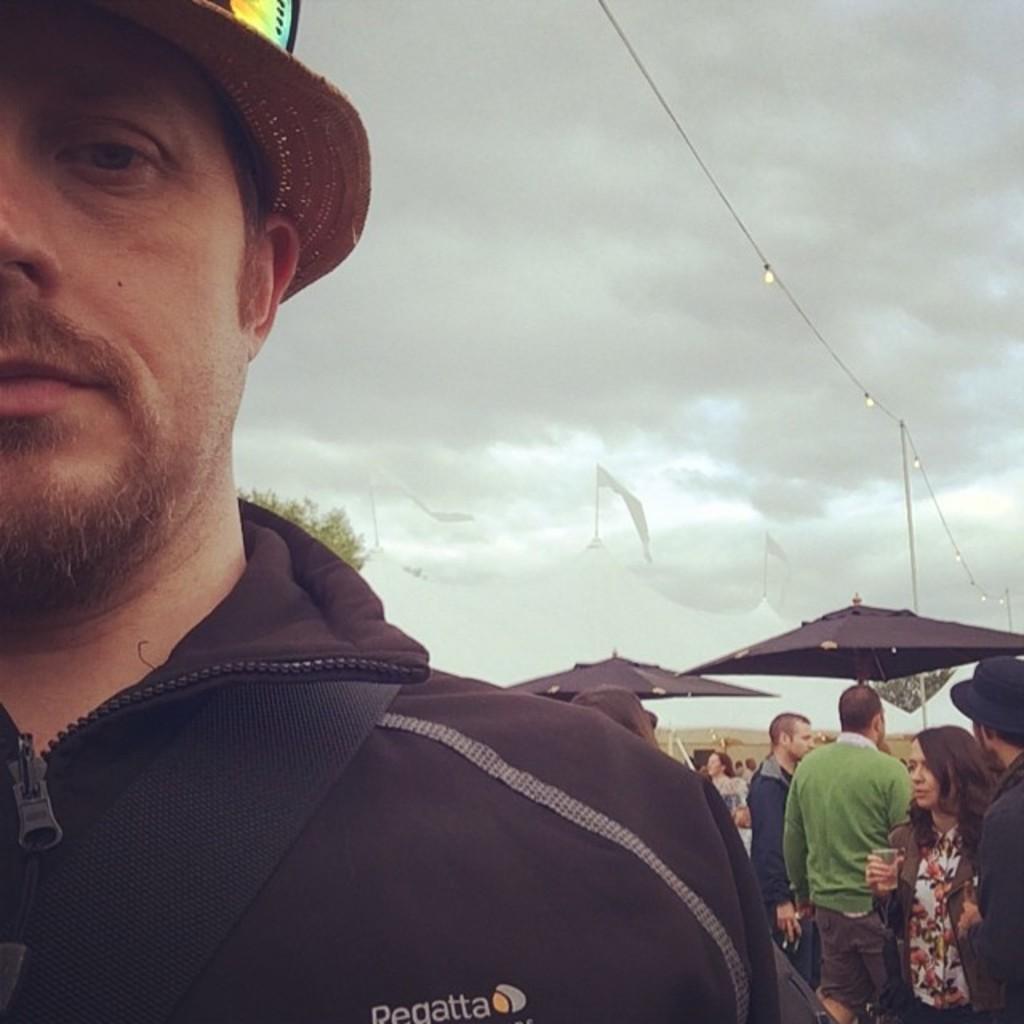Could you give a brief overview of what you see in this image? In this image, there is a man standing, he is wearing a hat, we can see some people standing and there are two black umbrellas, at the top there is a sky which is cloudy. 